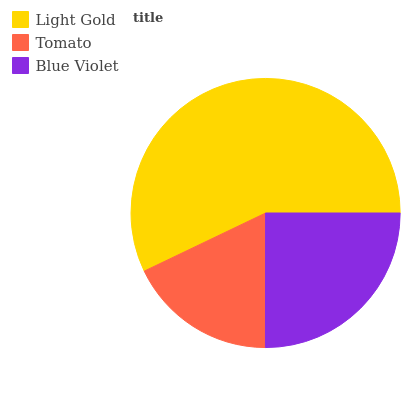Is Tomato the minimum?
Answer yes or no. Yes. Is Light Gold the maximum?
Answer yes or no. Yes. Is Blue Violet the minimum?
Answer yes or no. No. Is Blue Violet the maximum?
Answer yes or no. No. Is Blue Violet greater than Tomato?
Answer yes or no. Yes. Is Tomato less than Blue Violet?
Answer yes or no. Yes. Is Tomato greater than Blue Violet?
Answer yes or no. No. Is Blue Violet less than Tomato?
Answer yes or no. No. Is Blue Violet the high median?
Answer yes or no. Yes. Is Blue Violet the low median?
Answer yes or no. Yes. Is Light Gold the high median?
Answer yes or no. No. Is Tomato the low median?
Answer yes or no. No. 